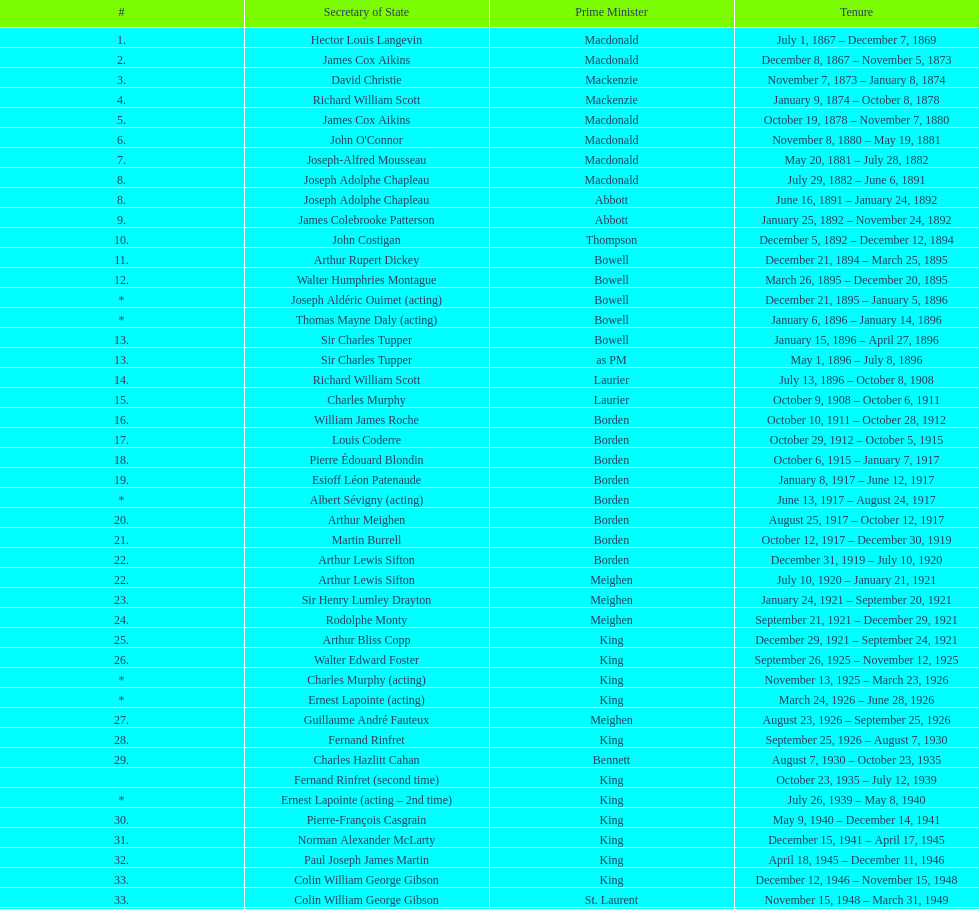Who was thompson's secretary of state? John Costigan. 